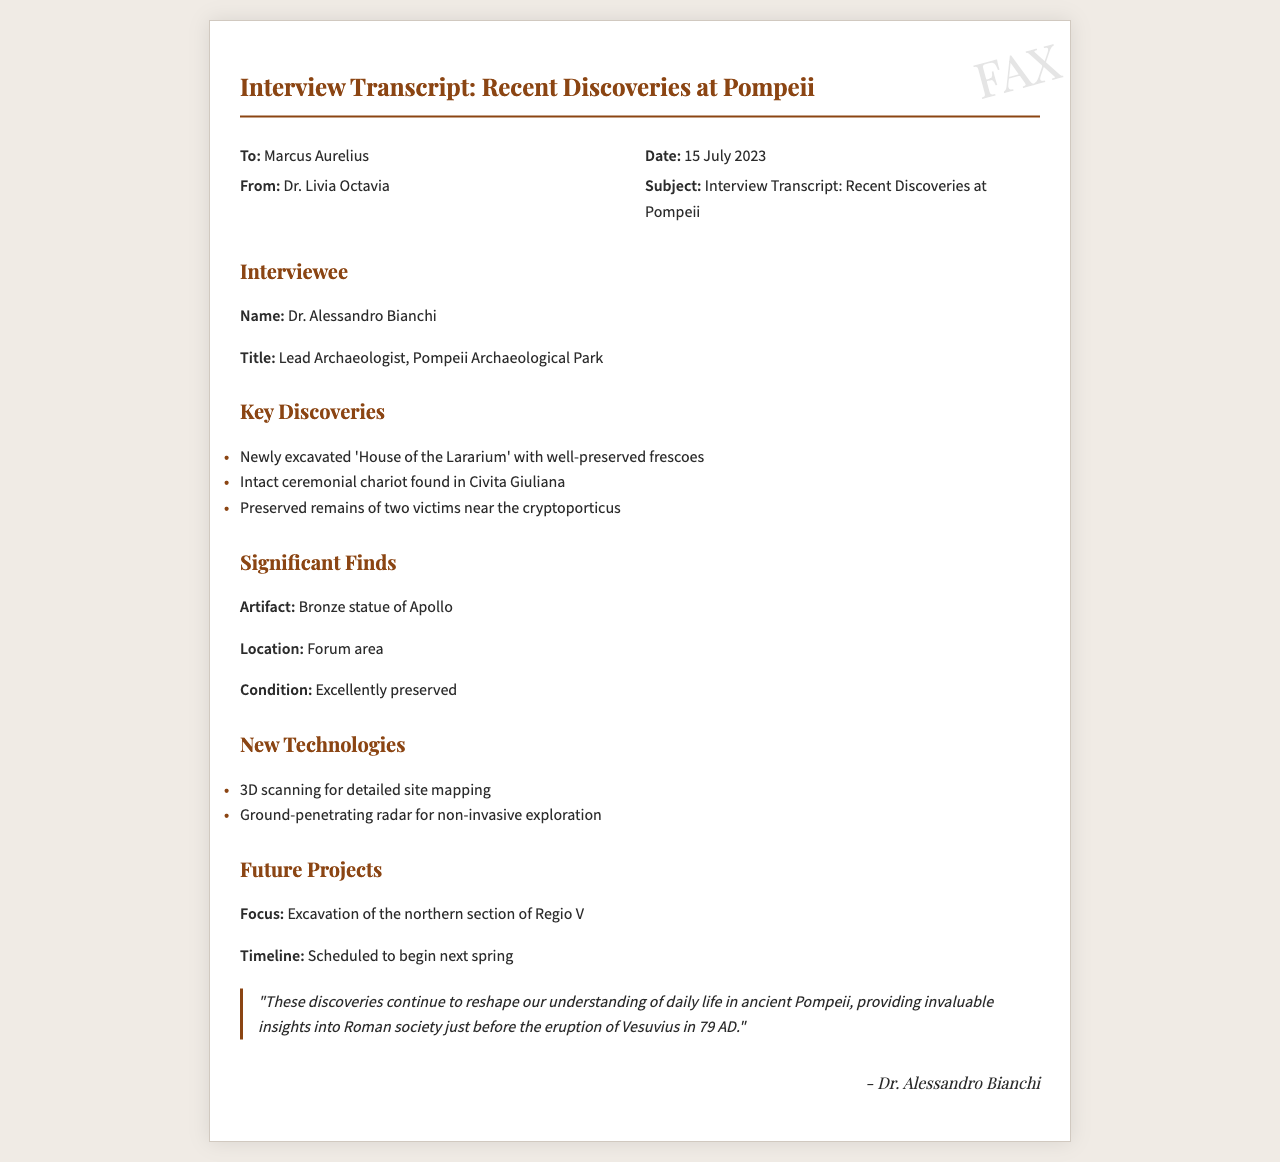What is the name of the lead archaeologist? The document identifies Dr. Alessandro Bianchi as the lead archaeologist at Pompeii Archaeological Park.
Answer: Dr. Alessandro Bianchi What is the title of Dr. Bianchi? The transcript states that Dr. Bianchi holds the title of Lead Archaeologist.
Answer: Lead Archaeologist What significant artifact was found in the Forum area? According to the document, the significant artifact discovered was a Bronze statue of Apollo.
Answer: Bronze statue of Apollo When is the excavation of the northern section of Regio V scheduled to begin? The timeline for the excavation of the northern section of Regio V is mentioned as scheduled to begin next spring.
Answer: Next spring What new technology is used for detailed site mapping? The document mentions that 3D scanning is a new technology used for detailed site mapping.
Answer: 3D scanning How many victims' remains were preserved near the cryptoporticus? The transcript states that the preserved remains of two victims were found near the cryptoporticus.
Answer: Two victims What was found in Civita Giuliana? The document reports that an intact ceremonial chariot was found in Civita Giuliana.
Answer: Intact ceremonial chariot What is the focus of future projects mentioned? According to the document, the focus of future projects is the excavation of the northern section of Regio V.
Answer: Excavation of the northern section of Regio V What date was the interview transcript dated? The document indicates that the interview transcript was dated 15 July 2023.
Answer: 15 July 2023 